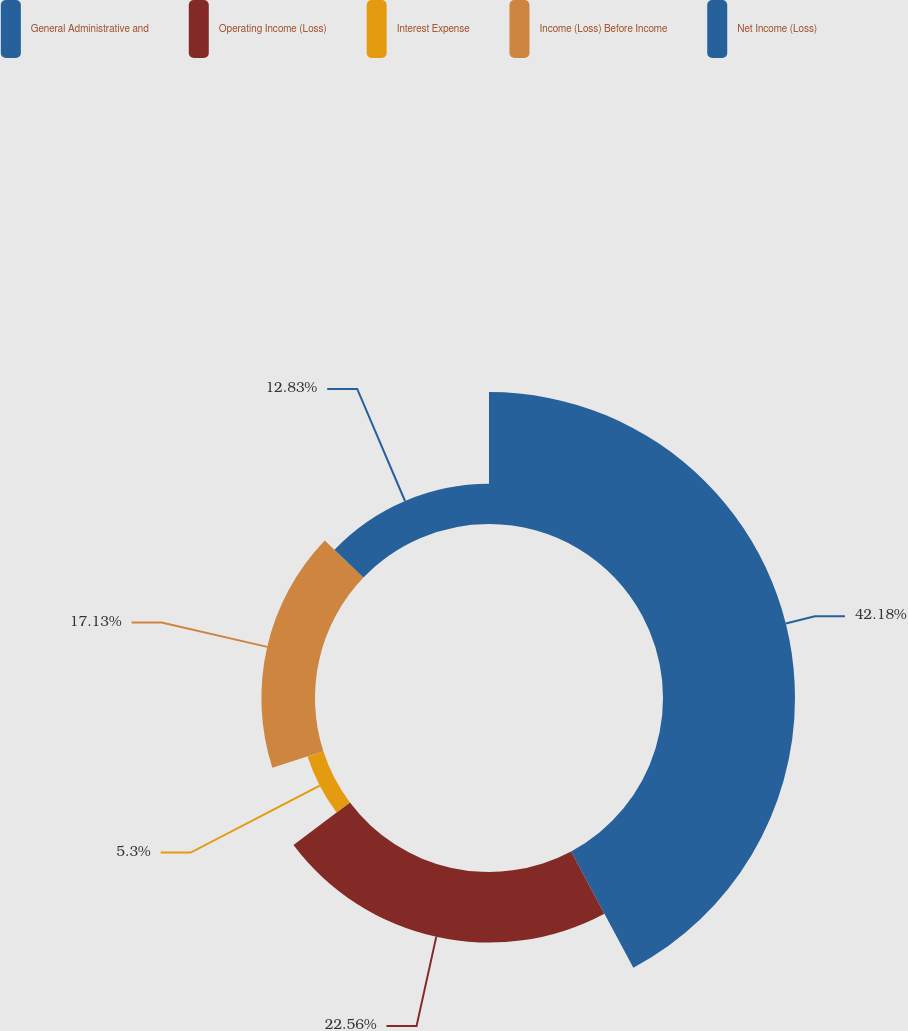<chart> <loc_0><loc_0><loc_500><loc_500><pie_chart><fcel>General Administrative and<fcel>Operating Income (Loss)<fcel>Interest Expense<fcel>Income (Loss) Before Income<fcel>Net Income (Loss)<nl><fcel>42.18%<fcel>22.56%<fcel>5.3%<fcel>17.13%<fcel>12.83%<nl></chart> 